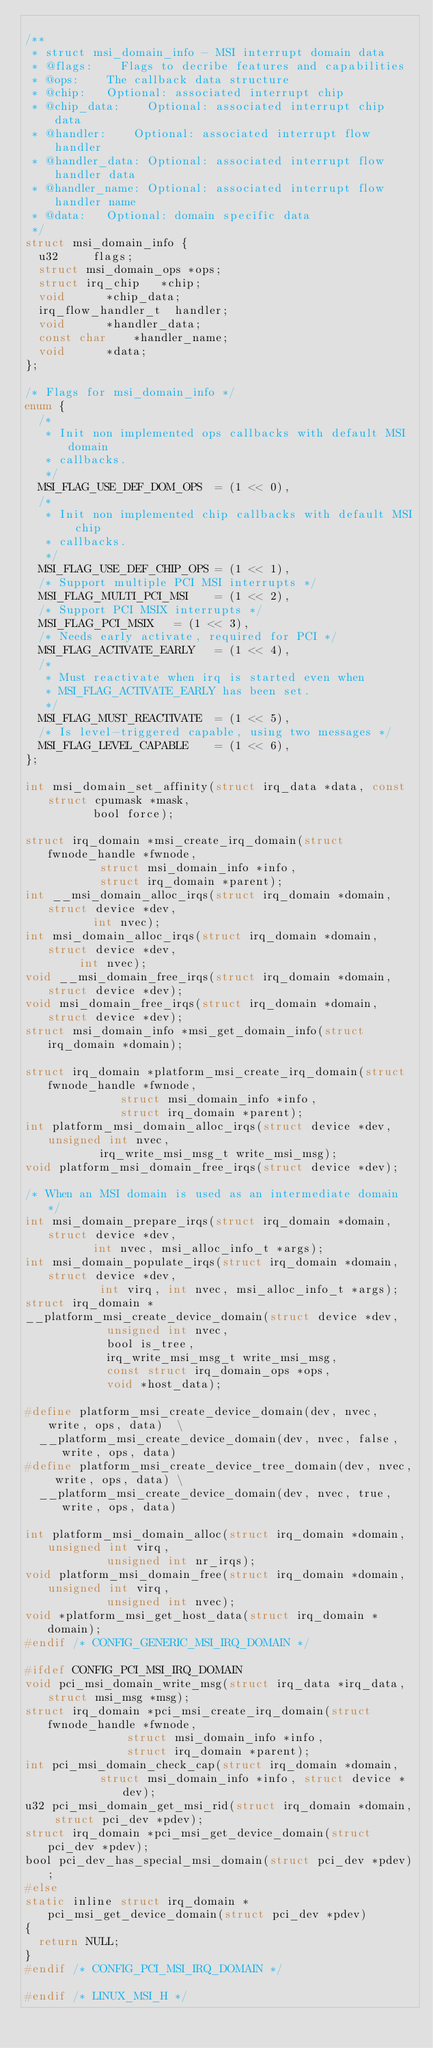Convert code to text. <code><loc_0><loc_0><loc_500><loc_500><_C_>
/**
 * struct msi_domain_info - MSI interrupt domain data
 * @flags:		Flags to decribe features and capabilities
 * @ops:		The callback data structure
 * @chip:		Optional: associated interrupt chip
 * @chip_data:		Optional: associated interrupt chip data
 * @handler:		Optional: associated interrupt flow handler
 * @handler_data:	Optional: associated interrupt flow handler data
 * @handler_name:	Optional: associated interrupt flow handler name
 * @data:		Optional: domain specific data
 */
struct msi_domain_info {
	u32			flags;
	struct msi_domain_ops	*ops;
	struct irq_chip		*chip;
	void			*chip_data;
	irq_flow_handler_t	handler;
	void			*handler_data;
	const char		*handler_name;
	void			*data;
};

/* Flags for msi_domain_info */
enum {
	/*
	 * Init non implemented ops callbacks with default MSI domain
	 * callbacks.
	 */
	MSI_FLAG_USE_DEF_DOM_OPS	= (1 << 0),
	/*
	 * Init non implemented chip callbacks with default MSI chip
	 * callbacks.
	 */
	MSI_FLAG_USE_DEF_CHIP_OPS	= (1 << 1),
	/* Support multiple PCI MSI interrupts */
	MSI_FLAG_MULTI_PCI_MSI		= (1 << 2),
	/* Support PCI MSIX interrupts */
	MSI_FLAG_PCI_MSIX		= (1 << 3),
	/* Needs early activate, required for PCI */
	MSI_FLAG_ACTIVATE_EARLY		= (1 << 4),
	/*
	 * Must reactivate when irq is started even when
	 * MSI_FLAG_ACTIVATE_EARLY has been set.
	 */
	MSI_FLAG_MUST_REACTIVATE	= (1 << 5),
	/* Is level-triggered capable, using two messages */
	MSI_FLAG_LEVEL_CAPABLE		= (1 << 6),
};

int msi_domain_set_affinity(struct irq_data *data, const struct cpumask *mask,
			    bool force);

struct irq_domain *msi_create_irq_domain(struct fwnode_handle *fwnode,
					 struct msi_domain_info *info,
					 struct irq_domain *parent);
int __msi_domain_alloc_irqs(struct irq_domain *domain, struct device *dev,
			    int nvec);
int msi_domain_alloc_irqs(struct irq_domain *domain, struct device *dev,
			  int nvec);
void __msi_domain_free_irqs(struct irq_domain *domain, struct device *dev);
void msi_domain_free_irqs(struct irq_domain *domain, struct device *dev);
struct msi_domain_info *msi_get_domain_info(struct irq_domain *domain);

struct irq_domain *platform_msi_create_irq_domain(struct fwnode_handle *fwnode,
						  struct msi_domain_info *info,
						  struct irq_domain *parent);
int platform_msi_domain_alloc_irqs(struct device *dev, unsigned int nvec,
				   irq_write_msi_msg_t write_msi_msg);
void platform_msi_domain_free_irqs(struct device *dev);

/* When an MSI domain is used as an intermediate domain */
int msi_domain_prepare_irqs(struct irq_domain *domain, struct device *dev,
			    int nvec, msi_alloc_info_t *args);
int msi_domain_populate_irqs(struct irq_domain *domain, struct device *dev,
			     int virq, int nvec, msi_alloc_info_t *args);
struct irq_domain *
__platform_msi_create_device_domain(struct device *dev,
				    unsigned int nvec,
				    bool is_tree,
				    irq_write_msi_msg_t write_msi_msg,
				    const struct irq_domain_ops *ops,
				    void *host_data);

#define platform_msi_create_device_domain(dev, nvec, write, ops, data)	\
	__platform_msi_create_device_domain(dev, nvec, false, write, ops, data)
#define platform_msi_create_device_tree_domain(dev, nvec, write, ops, data) \
	__platform_msi_create_device_domain(dev, nvec, true, write, ops, data)

int platform_msi_domain_alloc(struct irq_domain *domain, unsigned int virq,
			      unsigned int nr_irqs);
void platform_msi_domain_free(struct irq_domain *domain, unsigned int virq,
			      unsigned int nvec);
void *platform_msi_get_host_data(struct irq_domain *domain);
#endif /* CONFIG_GENERIC_MSI_IRQ_DOMAIN */

#ifdef CONFIG_PCI_MSI_IRQ_DOMAIN
void pci_msi_domain_write_msg(struct irq_data *irq_data, struct msi_msg *msg);
struct irq_domain *pci_msi_create_irq_domain(struct fwnode_handle *fwnode,
					     struct msi_domain_info *info,
					     struct irq_domain *parent);
int pci_msi_domain_check_cap(struct irq_domain *domain,
			     struct msi_domain_info *info, struct device *dev);
u32 pci_msi_domain_get_msi_rid(struct irq_domain *domain, struct pci_dev *pdev);
struct irq_domain *pci_msi_get_device_domain(struct pci_dev *pdev);
bool pci_dev_has_special_msi_domain(struct pci_dev *pdev);
#else
static inline struct irq_domain *pci_msi_get_device_domain(struct pci_dev *pdev)
{
	return NULL;
}
#endif /* CONFIG_PCI_MSI_IRQ_DOMAIN */

#endif /* LINUX_MSI_H */
</code> 